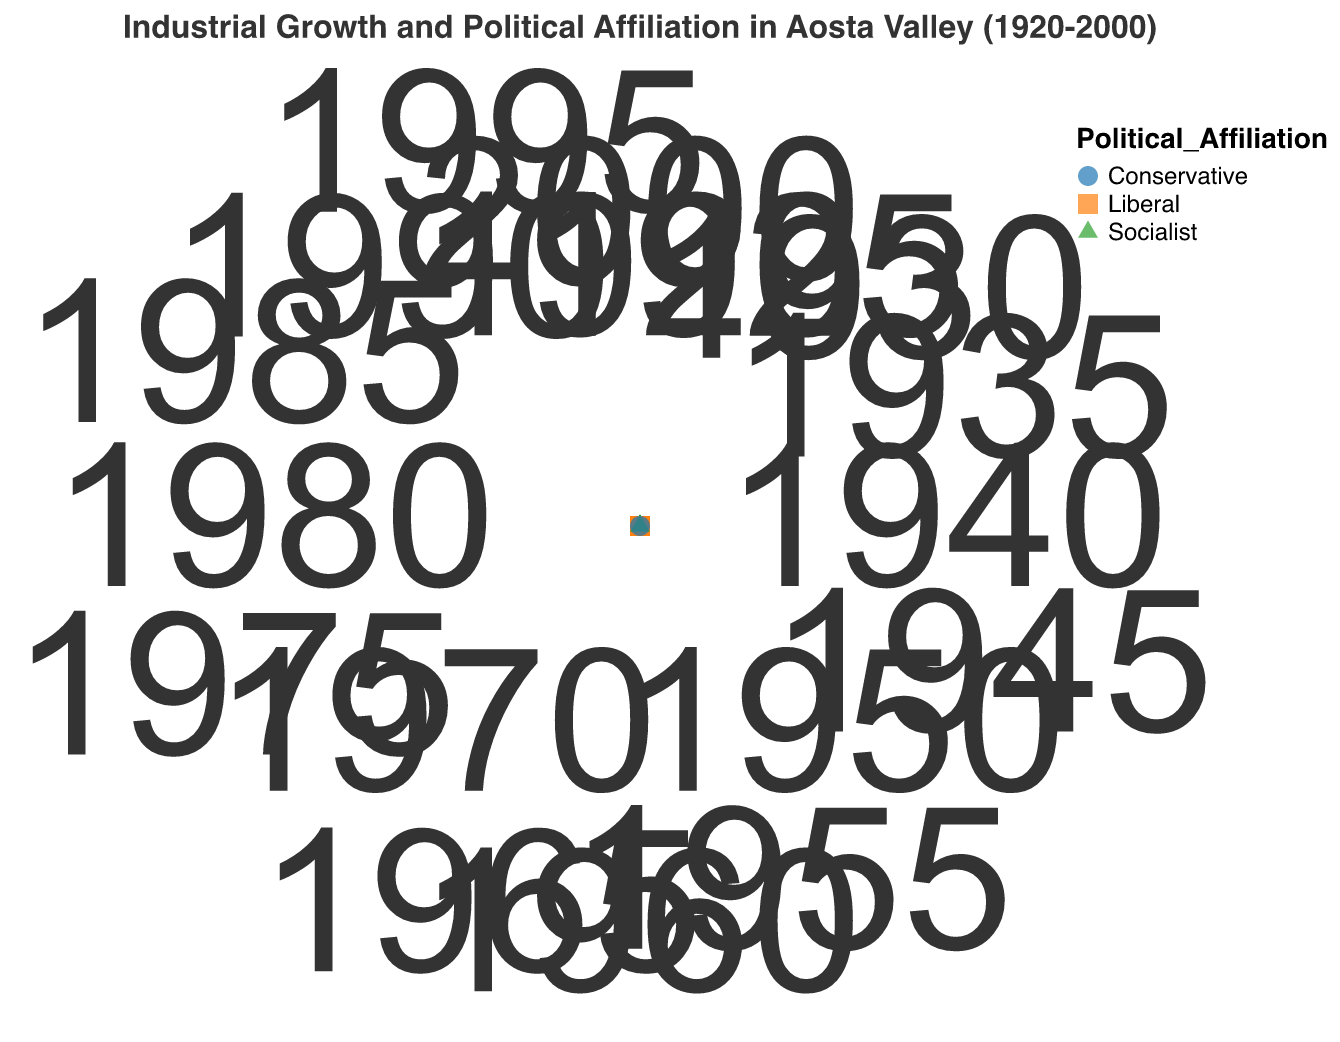What's the highest industrial growth rate associated with the Socialist political affiliation? From the plot, the Socialist political affiliation points are color-coded and the highest point reaching the outer edge is at a growth rate of 9.0.
Answer: 9.0 How many years between 1920 and 2000 had a Conservative political affiliation? Count the number of points with the Conservative label in the plot. They appear in 1920, 1925, 1940, 1950, 1970, and 2000, making it six years.
Answer: 6 Which political affiliation occurred the least frequently between 1920 and 2000? Compare the frequency of each political affiliation in the plot. Conservative has 6 years, Liberal has 5 years, and Socialist has 6 years. Therefore, Liberal has the least frequency.
Answer: Liberal During which year did the highest industrial growth rate occur? Identify the outermost point on the plot. It occurs in 1975 with an industrial growth rate of 9.0.
Answer: 1975 What is the average industrial growth rate during the years under Liberal political affiliation? The years with Liberal political affiliation are 1930 (4.5), 1935 (5.0), 1945 (6.5), 1980 (6.0), 1990 (5.5). Sum these up: 27.5, and divide by the number of years (5) to get the average: 27.5 / 5 = 5.5
Answer: 5.5 What is the difference in industrial growth rate between 1920 and 1970? Locate the data points for 1920 (2.5) and 1970 (3.5) and subtract: 3.5 - 2.5 = 1.0
Answer: 1.0 Which political affiliation is associated with the highest average industrial growth rate? Calculate the average growth rate for each affiliation: 
- Socialist: (7.0 + 7.5 + 8.0 + 9.0 + 8.5 + 7.5) / 6 = 8.08 
- Liberal: (4.5 + 5.0 + 6.5 + 6.0 + 5.5) / 5 = 5.5 
- Conservative: (2.5 + 3.0 + 4.0 + 3.5 + 3.5 + 4.0) / 6 = 3.42 
The highest average is for Socialist.
Answer: Socialist How does the industrial growth rate in 1940 compare to that in 1980? Identify the growth rates in the plot for 1940 (4.0) and 1980 (6.0): 6.0 is greater than 4.0 by 2.0.
Answer: 1980 is higher by 2.0 